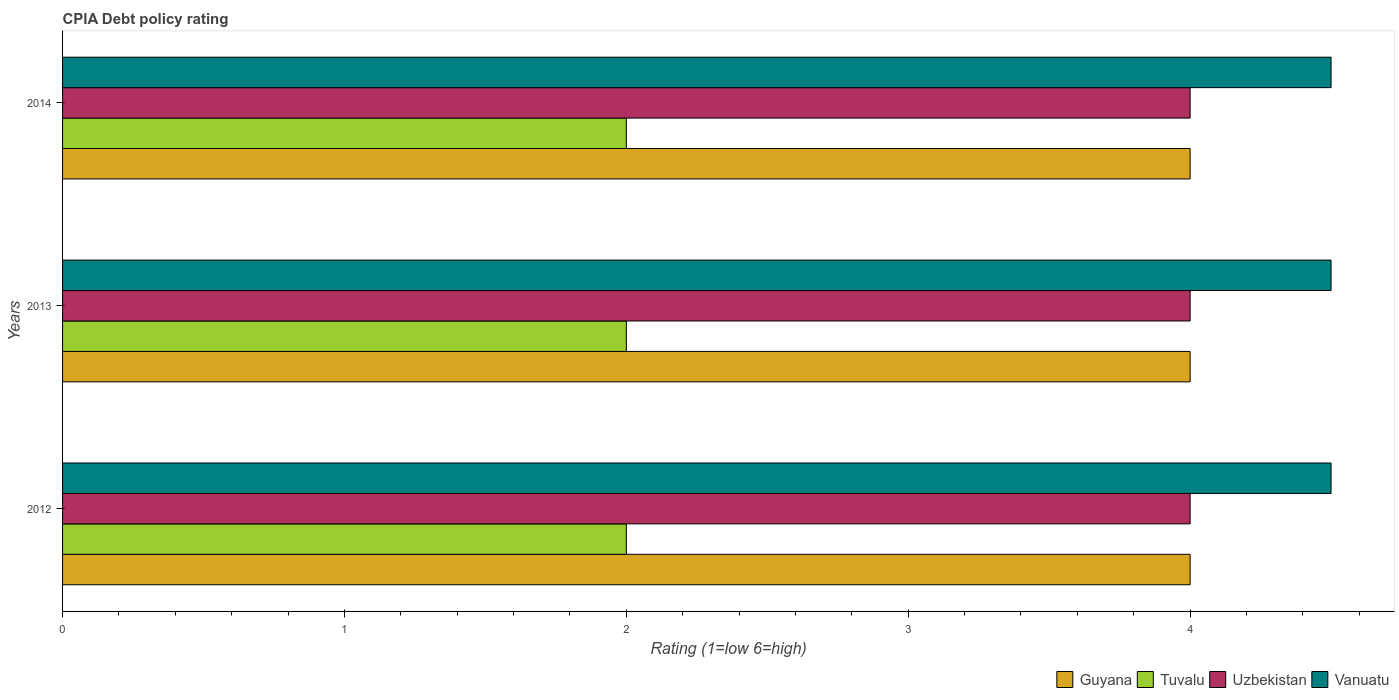Are the number of bars per tick equal to the number of legend labels?
Offer a very short reply. Yes. What is the label of the 1st group of bars from the top?
Offer a very short reply. 2014. Across all years, what is the maximum CPIA rating in Uzbekistan?
Provide a short and direct response. 4. Across all years, what is the minimum CPIA rating in Uzbekistan?
Offer a terse response. 4. In which year was the CPIA rating in Vanuatu maximum?
Your answer should be very brief. 2012. In which year was the CPIA rating in Uzbekistan minimum?
Offer a very short reply. 2012. What is the total CPIA rating in Vanuatu in the graph?
Keep it short and to the point. 13.5. What is the difference between the CPIA rating in Uzbekistan in 2013 and that in 2014?
Provide a succinct answer. 0. In the year 2012, what is the difference between the CPIA rating in Uzbekistan and CPIA rating in Tuvalu?
Ensure brevity in your answer.  2. In how many years, is the CPIA rating in Tuvalu greater than 2.2 ?
Provide a succinct answer. 0. What is the ratio of the CPIA rating in Uzbekistan in 2013 to that in 2014?
Your answer should be very brief. 1. What is the difference between the highest and the second highest CPIA rating in Tuvalu?
Your answer should be very brief. 0. In how many years, is the CPIA rating in Uzbekistan greater than the average CPIA rating in Uzbekistan taken over all years?
Offer a terse response. 0. What does the 2nd bar from the top in 2012 represents?
Make the answer very short. Uzbekistan. What does the 4th bar from the bottom in 2013 represents?
Offer a very short reply. Vanuatu. Is it the case that in every year, the sum of the CPIA rating in Vanuatu and CPIA rating in Tuvalu is greater than the CPIA rating in Guyana?
Your response must be concise. Yes. How many bars are there?
Give a very brief answer. 12. Are all the bars in the graph horizontal?
Your answer should be compact. Yes. How many years are there in the graph?
Ensure brevity in your answer.  3. What is the difference between two consecutive major ticks on the X-axis?
Provide a succinct answer. 1. Does the graph contain any zero values?
Your answer should be very brief. No. How many legend labels are there?
Ensure brevity in your answer.  4. What is the title of the graph?
Your response must be concise. CPIA Debt policy rating. What is the Rating (1=low 6=high) of Guyana in 2012?
Make the answer very short. 4. What is the Rating (1=low 6=high) of Tuvalu in 2012?
Keep it short and to the point. 2. What is the Rating (1=low 6=high) of Tuvalu in 2013?
Provide a short and direct response. 2. What is the Rating (1=low 6=high) in Vanuatu in 2013?
Offer a terse response. 4.5. What is the Rating (1=low 6=high) of Guyana in 2014?
Provide a short and direct response. 4. What is the Rating (1=low 6=high) of Tuvalu in 2014?
Offer a terse response. 2. What is the Rating (1=low 6=high) in Vanuatu in 2014?
Your response must be concise. 4.5. Across all years, what is the maximum Rating (1=low 6=high) in Guyana?
Your response must be concise. 4. Across all years, what is the maximum Rating (1=low 6=high) in Tuvalu?
Provide a succinct answer. 2. Across all years, what is the maximum Rating (1=low 6=high) of Uzbekistan?
Offer a terse response. 4. Across all years, what is the maximum Rating (1=low 6=high) of Vanuatu?
Give a very brief answer. 4.5. Across all years, what is the minimum Rating (1=low 6=high) in Guyana?
Your response must be concise. 4. Across all years, what is the minimum Rating (1=low 6=high) in Tuvalu?
Provide a succinct answer. 2. Across all years, what is the minimum Rating (1=low 6=high) in Uzbekistan?
Your answer should be compact. 4. What is the total Rating (1=low 6=high) of Guyana in the graph?
Provide a succinct answer. 12. What is the total Rating (1=low 6=high) in Uzbekistan in the graph?
Provide a short and direct response. 12. What is the difference between the Rating (1=low 6=high) of Guyana in 2012 and that in 2013?
Offer a very short reply. 0. What is the difference between the Rating (1=low 6=high) in Uzbekistan in 2012 and that in 2013?
Offer a terse response. 0. What is the difference between the Rating (1=low 6=high) of Vanuatu in 2012 and that in 2013?
Give a very brief answer. 0. What is the difference between the Rating (1=low 6=high) of Tuvalu in 2013 and that in 2014?
Your answer should be compact. 0. What is the difference between the Rating (1=low 6=high) in Uzbekistan in 2013 and that in 2014?
Ensure brevity in your answer.  0. What is the difference between the Rating (1=low 6=high) of Guyana in 2012 and the Rating (1=low 6=high) of Tuvalu in 2013?
Your response must be concise. 2. What is the difference between the Rating (1=low 6=high) in Tuvalu in 2012 and the Rating (1=low 6=high) in Uzbekistan in 2013?
Make the answer very short. -2. What is the difference between the Rating (1=low 6=high) of Uzbekistan in 2012 and the Rating (1=low 6=high) of Vanuatu in 2013?
Keep it short and to the point. -0.5. What is the difference between the Rating (1=low 6=high) in Guyana in 2012 and the Rating (1=low 6=high) in Uzbekistan in 2014?
Provide a short and direct response. 0. What is the difference between the Rating (1=low 6=high) of Tuvalu in 2013 and the Rating (1=low 6=high) of Uzbekistan in 2014?
Your response must be concise. -2. What is the average Rating (1=low 6=high) in Tuvalu per year?
Your response must be concise. 2. In the year 2012, what is the difference between the Rating (1=low 6=high) of Guyana and Rating (1=low 6=high) of Tuvalu?
Keep it short and to the point. 2. In the year 2012, what is the difference between the Rating (1=low 6=high) of Tuvalu and Rating (1=low 6=high) of Uzbekistan?
Offer a very short reply. -2. In the year 2012, what is the difference between the Rating (1=low 6=high) in Tuvalu and Rating (1=low 6=high) in Vanuatu?
Give a very brief answer. -2.5. In the year 2012, what is the difference between the Rating (1=low 6=high) of Uzbekistan and Rating (1=low 6=high) of Vanuatu?
Offer a terse response. -0.5. In the year 2013, what is the difference between the Rating (1=low 6=high) in Guyana and Rating (1=low 6=high) in Tuvalu?
Make the answer very short. 2. In the year 2013, what is the difference between the Rating (1=low 6=high) of Guyana and Rating (1=low 6=high) of Uzbekistan?
Your answer should be compact. 0. In the year 2013, what is the difference between the Rating (1=low 6=high) of Guyana and Rating (1=low 6=high) of Vanuatu?
Provide a short and direct response. -0.5. In the year 2014, what is the difference between the Rating (1=low 6=high) of Tuvalu and Rating (1=low 6=high) of Vanuatu?
Provide a short and direct response. -2.5. In the year 2014, what is the difference between the Rating (1=low 6=high) in Uzbekistan and Rating (1=low 6=high) in Vanuatu?
Your answer should be very brief. -0.5. What is the ratio of the Rating (1=low 6=high) in Guyana in 2012 to that in 2014?
Provide a short and direct response. 1. What is the ratio of the Rating (1=low 6=high) of Vanuatu in 2012 to that in 2014?
Offer a terse response. 1. What is the ratio of the Rating (1=low 6=high) of Guyana in 2013 to that in 2014?
Your response must be concise. 1. What is the ratio of the Rating (1=low 6=high) in Tuvalu in 2013 to that in 2014?
Offer a very short reply. 1. What is the ratio of the Rating (1=low 6=high) of Uzbekistan in 2013 to that in 2014?
Ensure brevity in your answer.  1. What is the difference between the highest and the second highest Rating (1=low 6=high) in Guyana?
Your answer should be very brief. 0. What is the difference between the highest and the second highest Rating (1=low 6=high) of Vanuatu?
Provide a succinct answer. 0. What is the difference between the highest and the lowest Rating (1=low 6=high) of Guyana?
Offer a terse response. 0. What is the difference between the highest and the lowest Rating (1=low 6=high) in Uzbekistan?
Offer a terse response. 0. 